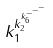Convert formula to latex. <formula><loc_0><loc_0><loc_500><loc_500>k _ { 1 } ^ { k _ { 2 } ^ { k _ { 6 } ^ { - ^ { - ^ { - } } } } }</formula> 